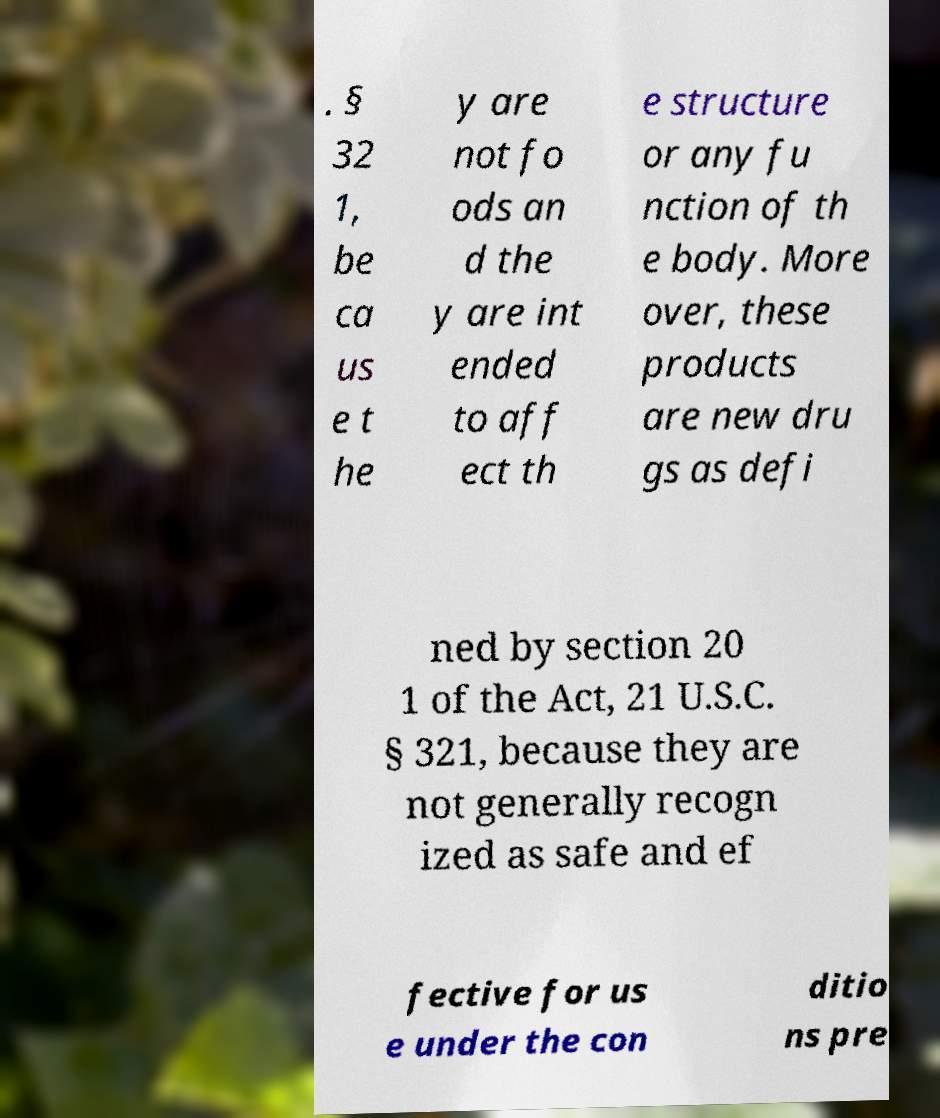For documentation purposes, I need the text within this image transcribed. Could you provide that? . § 32 1, be ca us e t he y are not fo ods an d the y are int ended to aff ect th e structure or any fu nction of th e body. More over, these products are new dru gs as defi ned by section 20 1 of the Act, 21 U.S.C. § 321, because they are not generally recogn ized as safe and ef fective for us e under the con ditio ns pre 